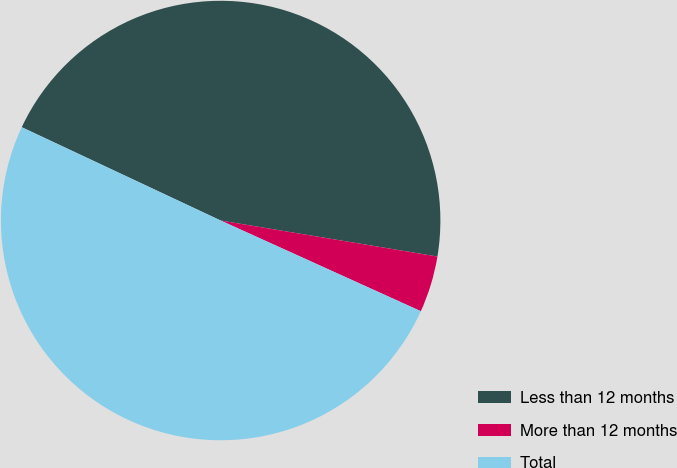Convert chart to OTSL. <chart><loc_0><loc_0><loc_500><loc_500><pie_chart><fcel>Less than 12 months<fcel>More than 12 months<fcel>Total<nl><fcel>45.64%<fcel>4.15%<fcel>50.21%<nl></chart> 